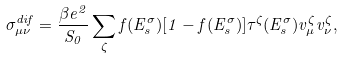Convert formula to latex. <formula><loc_0><loc_0><loc_500><loc_500>\sigma _ { \mu \nu } ^ { d i f } = \frac { \beta e ^ { 2 } } { S _ { 0 } } \sum _ { \zeta } f ( E _ { s } ^ { \sigma } ) [ 1 - f ( E _ { s } ^ { \sigma } ) ] \tau ^ { \zeta } ( E _ { s } ^ { \sigma } ) v _ { \mu } ^ { \zeta } v _ { \nu } ^ { \zeta } ,</formula> 